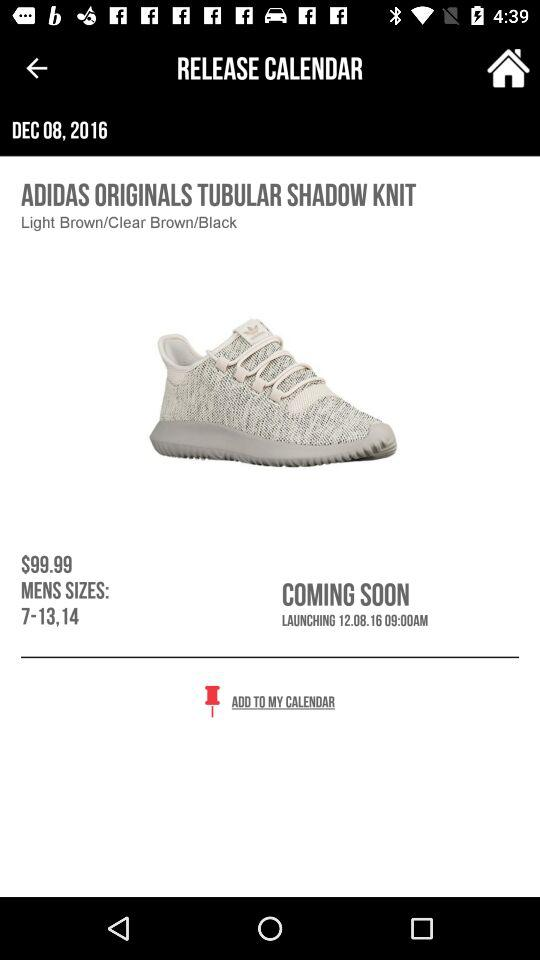What is the price of men's shoes? The price is $99.99. 